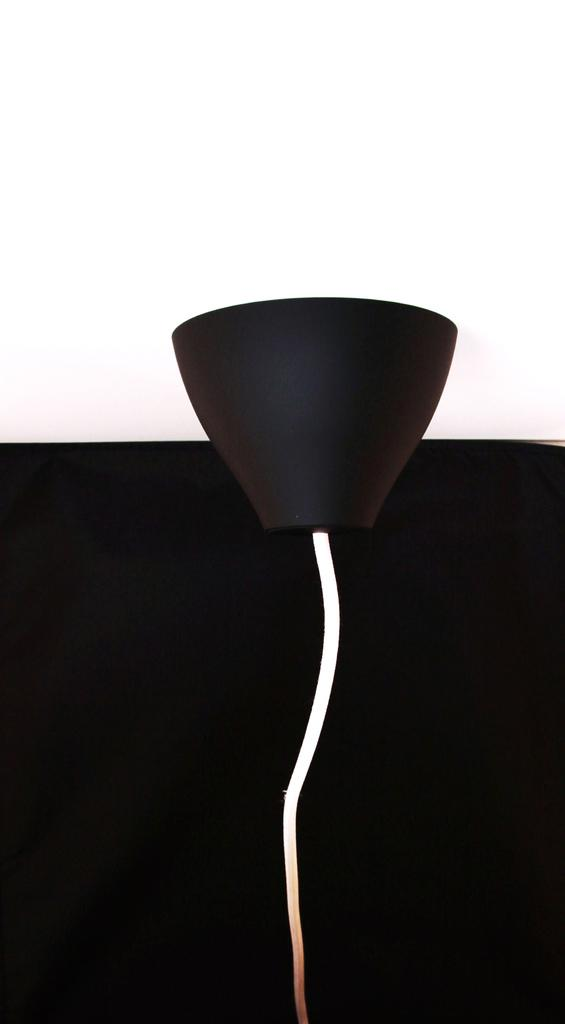What is the color of the main object in the image? The main object in the image is black. Can you describe the white light in the image? The white light is in the form of a wire. What color is the background of the image? The background of the image is black. How much of the background is visible in the image? Half of the background is visible in the image. What type of apple is being used as a car in the image? There is no apple or car present in the image. 